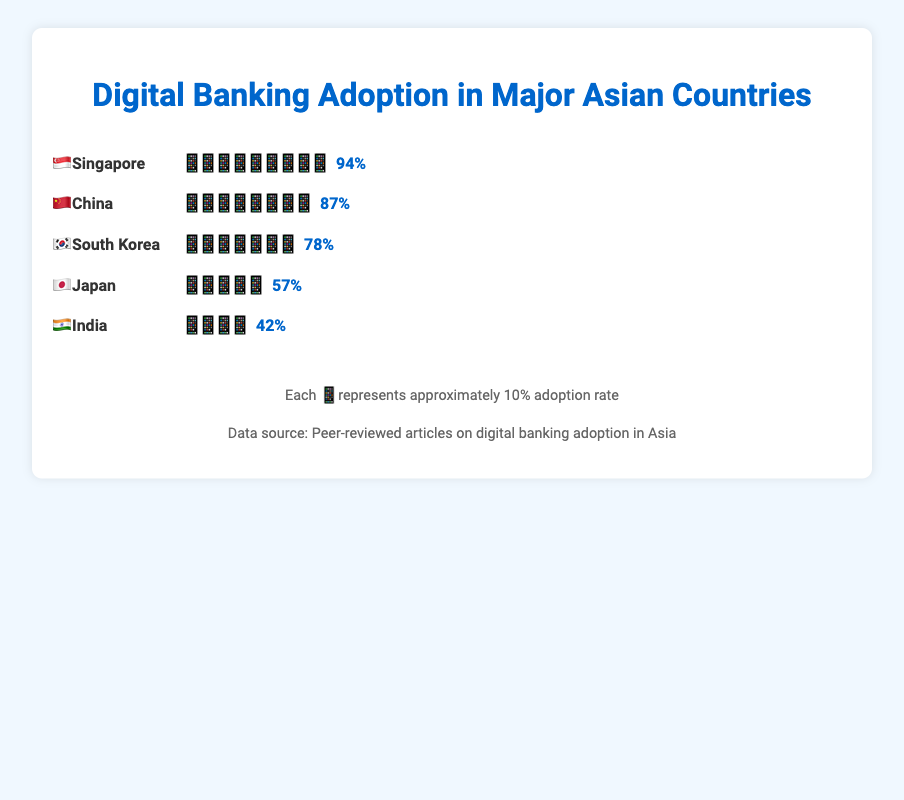what's the digital banking adoption rate for Singapore? The plot shows 🇸🇬 Singapore with 9 smartphone icons and a rate of 94%.
Answer: 94% which country has the highest digital banking adoption rate? The plot shows that 🇸🇬 Singapore has the highest rate with 94%.
Answer: Singapore how does Japan's adoption rate compare to China's? Japan's rate is 57% and China's rate is 87%. Japan's rate is 30 percentage points lower.
Answer: Japan's is 30% lower which two countries have the largest difference in adoption rates? Singapore has the highest rate at 94%, and India has the lowest rate at 42%. The difference is 52 percentage points.
Answer: Singapore and India how many smartphone icons would represent China's adoption rate? China has an adoption rate represented by 8 smartphone icons. Each icon represents approximately 10%.
Answer: 8 icons what's the combined adoption rate of Japan and India? Japan has 57% and India has 42%. Adding them gives 99%.
Answer: 99% what's the average adoption rate across all five countries? Sum the adoption rates of all countries (57% + 78% + 87% + 42% + 94%) and divide by the number of countries (5). Average is (57+78+87+42+94)/5 = 71.6%.
Answer: 71.6% list the countries with adoption rates greater than 70% The plot shows South Korea, China, and Singapore with rates higher than 70%.
Answer: South Korea, China, Singapore how many countries have less than 6 smartphone icons representing their adoption rate? Japan and India have less than 6 icons each, representing their rates.
Answer: 2 countries if each smartphone represents 10%, how many phones represent the total adoption rate for all countries combined? Sum the adoption rates of all countries (57% + 78% + 87% + 42% + 94%) to get 358%. 358/10 is 35.8, meaning roughly 36 icons.
Answer: 36 icons 